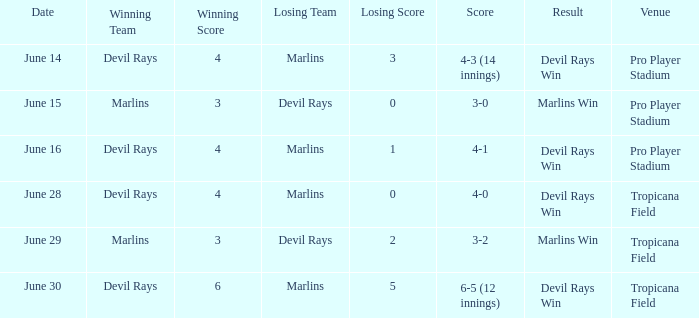What was the score on june 29 when the devil rays los? 3-2. 